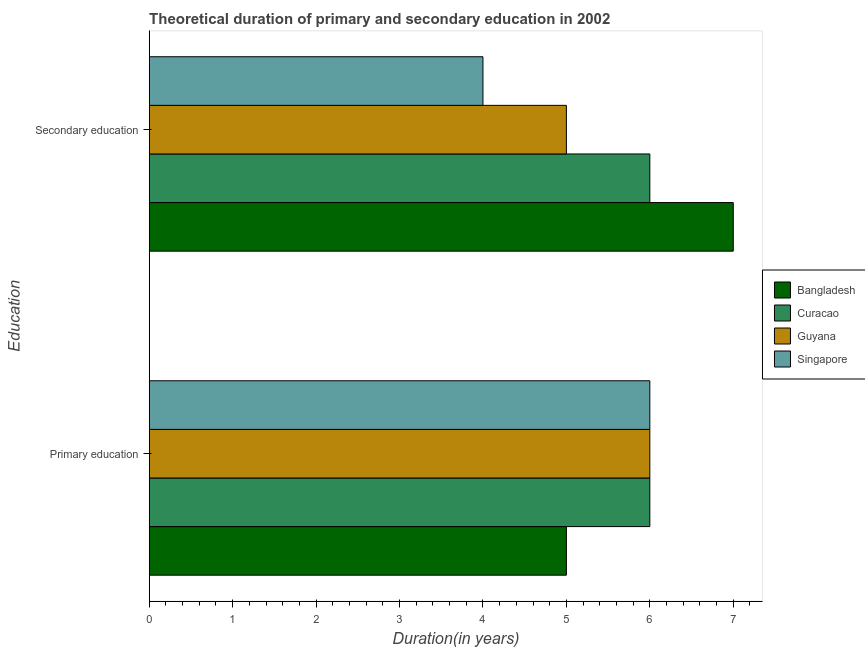Are the number of bars per tick equal to the number of legend labels?
Offer a very short reply. Yes. Are the number of bars on each tick of the Y-axis equal?
Your answer should be very brief. Yes. How many bars are there on the 1st tick from the bottom?
Your answer should be very brief. 4. Across all countries, what is the maximum duration of secondary education?
Your response must be concise. 7. Across all countries, what is the minimum duration of primary education?
Your response must be concise. 5. In which country was the duration of secondary education minimum?
Your answer should be compact. Singapore. What is the total duration of primary education in the graph?
Your answer should be very brief. 23. What is the difference between the duration of secondary education in Singapore and that in Bangladesh?
Provide a succinct answer. -3. What is the difference between the duration of secondary education in Guyana and the duration of primary education in Bangladesh?
Keep it short and to the point. 0. What is the average duration of primary education per country?
Ensure brevity in your answer.  5.75. What is the difference between the duration of primary education and duration of secondary education in Bangladesh?
Your answer should be compact. -2. What is the ratio of the duration of secondary education in Curacao to that in Bangladesh?
Make the answer very short. 0.86. In how many countries, is the duration of secondary education greater than the average duration of secondary education taken over all countries?
Give a very brief answer. 2. What does the 3rd bar from the top in Primary education represents?
Ensure brevity in your answer.  Curacao. What does the 2nd bar from the bottom in Secondary education represents?
Keep it short and to the point. Curacao. How many countries are there in the graph?
Provide a succinct answer. 4. What is the difference between two consecutive major ticks on the X-axis?
Ensure brevity in your answer.  1. Does the graph contain grids?
Provide a short and direct response. No. How are the legend labels stacked?
Your answer should be very brief. Vertical. What is the title of the graph?
Provide a short and direct response. Theoretical duration of primary and secondary education in 2002. Does "Fragile and conflict affected situations" appear as one of the legend labels in the graph?
Your answer should be compact. No. What is the label or title of the X-axis?
Provide a succinct answer. Duration(in years). What is the label or title of the Y-axis?
Your answer should be compact. Education. What is the Duration(in years) of Curacao in Primary education?
Provide a succinct answer. 6. What is the Duration(in years) of Guyana in Primary education?
Keep it short and to the point. 6. What is the Duration(in years) in Singapore in Primary education?
Your answer should be compact. 6. What is the Duration(in years) of Bangladesh in Secondary education?
Provide a succinct answer. 7. What is the Duration(in years) of Curacao in Secondary education?
Ensure brevity in your answer.  6. What is the Duration(in years) of Guyana in Secondary education?
Ensure brevity in your answer.  5. What is the Duration(in years) of Singapore in Secondary education?
Keep it short and to the point. 4. Across all Education, what is the maximum Duration(in years) of Guyana?
Offer a terse response. 6. Across all Education, what is the minimum Duration(in years) of Curacao?
Provide a short and direct response. 6. Across all Education, what is the minimum Duration(in years) in Guyana?
Your answer should be compact. 5. Across all Education, what is the minimum Duration(in years) of Singapore?
Keep it short and to the point. 4. What is the total Duration(in years) in Curacao in the graph?
Provide a succinct answer. 12. What is the total Duration(in years) of Singapore in the graph?
Provide a succinct answer. 10. What is the difference between the Duration(in years) of Bangladesh in Primary education and that in Secondary education?
Offer a very short reply. -2. What is the difference between the Duration(in years) in Guyana in Primary education and that in Secondary education?
Provide a short and direct response. 1. What is the difference between the Duration(in years) in Bangladesh in Primary education and the Duration(in years) in Curacao in Secondary education?
Give a very brief answer. -1. What is the difference between the Duration(in years) in Bangladesh in Primary education and the Duration(in years) in Singapore in Secondary education?
Make the answer very short. 1. What is the average Duration(in years) of Bangladesh per Education?
Keep it short and to the point. 6. What is the average Duration(in years) of Singapore per Education?
Give a very brief answer. 5. What is the difference between the Duration(in years) in Bangladesh and Duration(in years) in Curacao in Primary education?
Provide a short and direct response. -1. What is the difference between the Duration(in years) of Bangladesh and Duration(in years) of Guyana in Primary education?
Give a very brief answer. -1. What is the difference between the Duration(in years) of Guyana and Duration(in years) of Singapore in Primary education?
Give a very brief answer. 0. What is the difference between the Duration(in years) in Bangladesh and Duration(in years) in Curacao in Secondary education?
Provide a succinct answer. 1. What is the difference between the Duration(in years) in Bangladesh and Duration(in years) in Guyana in Secondary education?
Provide a short and direct response. 2. What is the difference between the Duration(in years) in Curacao and Duration(in years) in Guyana in Secondary education?
Your answer should be very brief. 1. What is the ratio of the Duration(in years) in Bangladesh in Primary education to that in Secondary education?
Offer a very short reply. 0.71. What is the ratio of the Duration(in years) of Guyana in Primary education to that in Secondary education?
Make the answer very short. 1.2. What is the ratio of the Duration(in years) in Singapore in Primary education to that in Secondary education?
Your answer should be compact. 1.5. What is the difference between the highest and the second highest Duration(in years) in Guyana?
Provide a succinct answer. 1. What is the difference between the highest and the lowest Duration(in years) in Bangladesh?
Your answer should be compact. 2. What is the difference between the highest and the lowest Duration(in years) of Curacao?
Your answer should be compact. 0. What is the difference between the highest and the lowest Duration(in years) in Guyana?
Offer a terse response. 1. What is the difference between the highest and the lowest Duration(in years) of Singapore?
Give a very brief answer. 2. 